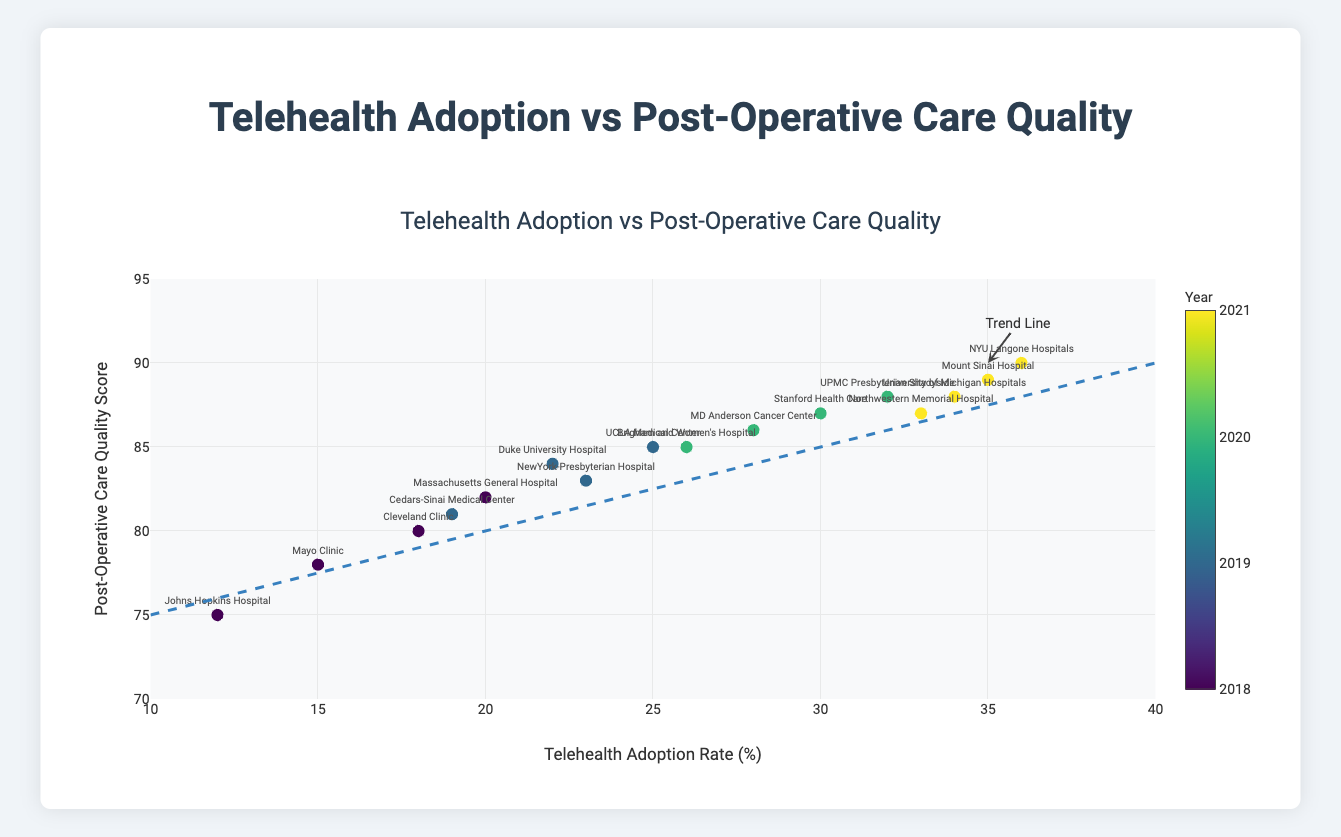What is the title of the plot? The title of the plot is displayed at the top center. It reads: "Telehealth Adoption vs Post-Operative Care Quality".
Answer: Telehealth Adoption vs Post-Operative Care Quality What do the axes represent? The x-axis represents the "Telehealth Adoption Rate (%)" while the y-axis represents the "Post-Operative Care Quality Score". These are indicated by the labels on the axes.
Answer: x-axis: Telehealth Adoption Rate (%), y-axis: Post-Operative Care Quality Score How many data points are in the plot? There are 16 data points in the plot, corresponding to the number of hospitals listed in the data. Each hospital is represented by a marker on the plot.
Answer: 16 Which hospital had the highest telehealth adoption rate? By examining the markers and their labels, the hospital with the highest telehealth adoption rate (36%) is "NYU Langone Hospitals". This is shown by the marker furthest to the right.
Answer: NYU Langone Hospitals What trend does the trend line indicate between telehealth adoption rate and post-operative care quality score? The trend line, which slants upwards from left to right, indicates a positive correlation: as the telehealth adoption rate increases, the post-operative care quality score also increases.
Answer: Positive correlation What was the telehealth adoption rate at Mayo Clinic in the year 2018? Referring to the hover template or identifying the specific marker and label for Mayo Clinic, the telehealth adoption rate in 2018 was 15%.
Answer: 15% Which hospital had a post-operative quality score of 90? The hospital with the post-operative quality score of 90 can be identified by locating the marker at y=90. The label for this marker indicates "NYU Langone Hospitals".
Answer: NYU Langone Hospitals How does the telehealth adoption rate for 2020 compare to that of 2018 on average? The adoption rates for 2020 are 30, 28, 26, and 32, which sum to 116. For 2018, the rates are 15, 18, 12, and 20, summing to 65. Averaging these values: 116/4 = 29 for 2020 and 65/4 = 16.25 for 2018. This indicates the rate is higher in 2020.
Answer: Higher in 2020 What is the most significant year observed for telehealth adoption increases? The color coding indicates the passage of time, with the color scale ranging from 2018 to 2021. By observing marker colors and trends, there is a noticeable jump in adoption rates in 2020 and 2021.
Answer: 2020 and 2021 Which hospital in 2019 had the highest post-op quality score? For 2019, examining the markers and labels, the hospital with the highest post-op quality score of 85 is "UCLA Medical Center".
Answer: UCLA Medical Center 